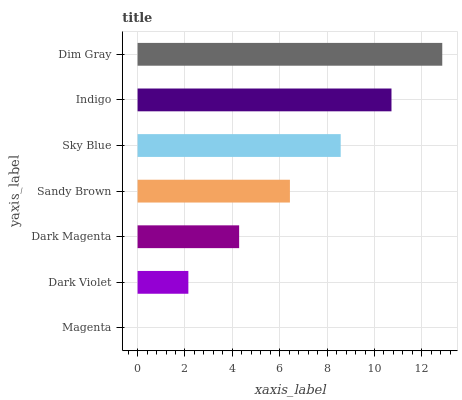Is Magenta the minimum?
Answer yes or no. Yes. Is Dim Gray the maximum?
Answer yes or no. Yes. Is Dark Violet the minimum?
Answer yes or no. No. Is Dark Violet the maximum?
Answer yes or no. No. Is Dark Violet greater than Magenta?
Answer yes or no. Yes. Is Magenta less than Dark Violet?
Answer yes or no. Yes. Is Magenta greater than Dark Violet?
Answer yes or no. No. Is Dark Violet less than Magenta?
Answer yes or no. No. Is Sandy Brown the high median?
Answer yes or no. Yes. Is Sandy Brown the low median?
Answer yes or no. Yes. Is Sky Blue the high median?
Answer yes or no. No. Is Dark Magenta the low median?
Answer yes or no. No. 